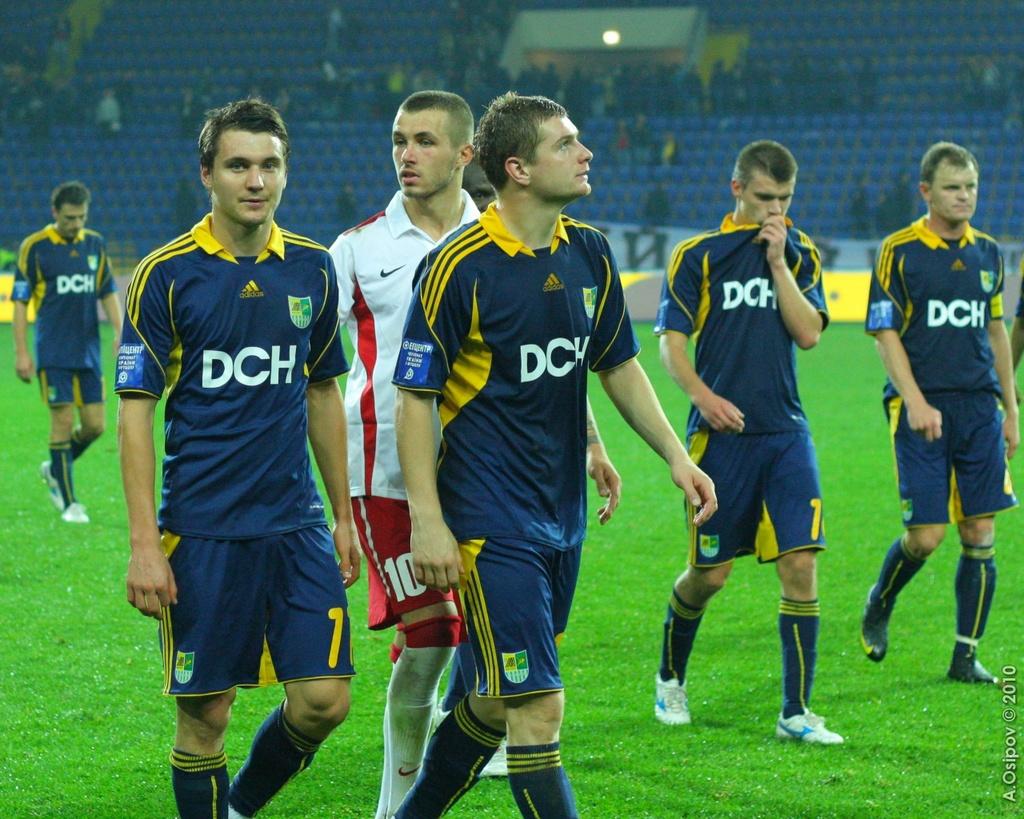What is the number of the player in the red shorts?
Your response must be concise. 10. 